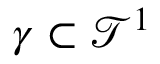<formula> <loc_0><loc_0><loc_500><loc_500>\gamma \subset \mathcal { T } ^ { 1 }</formula> 